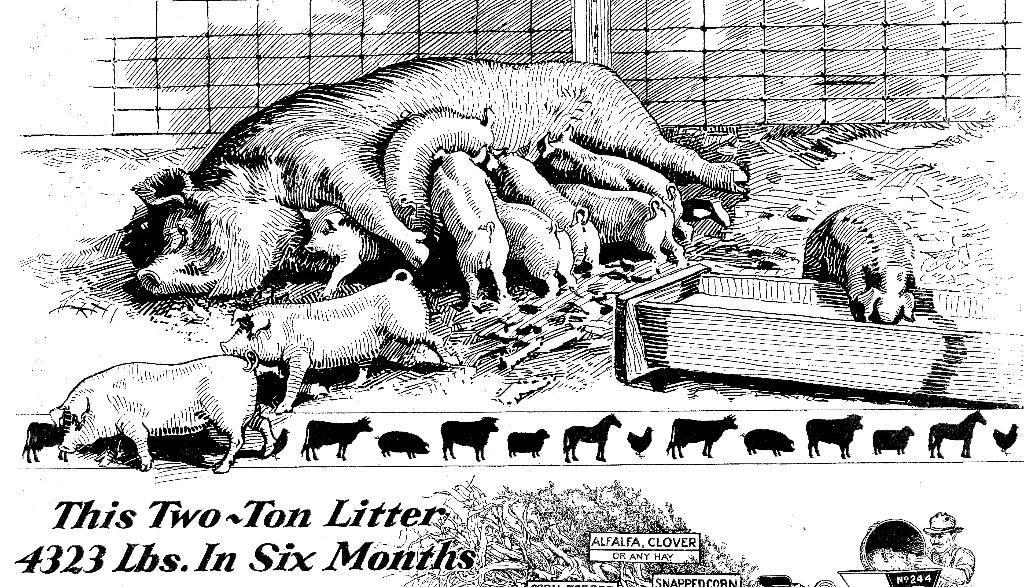Please provide a concise description of this image. In this picture we can see poster, on this poster we can see animals, person and text. 